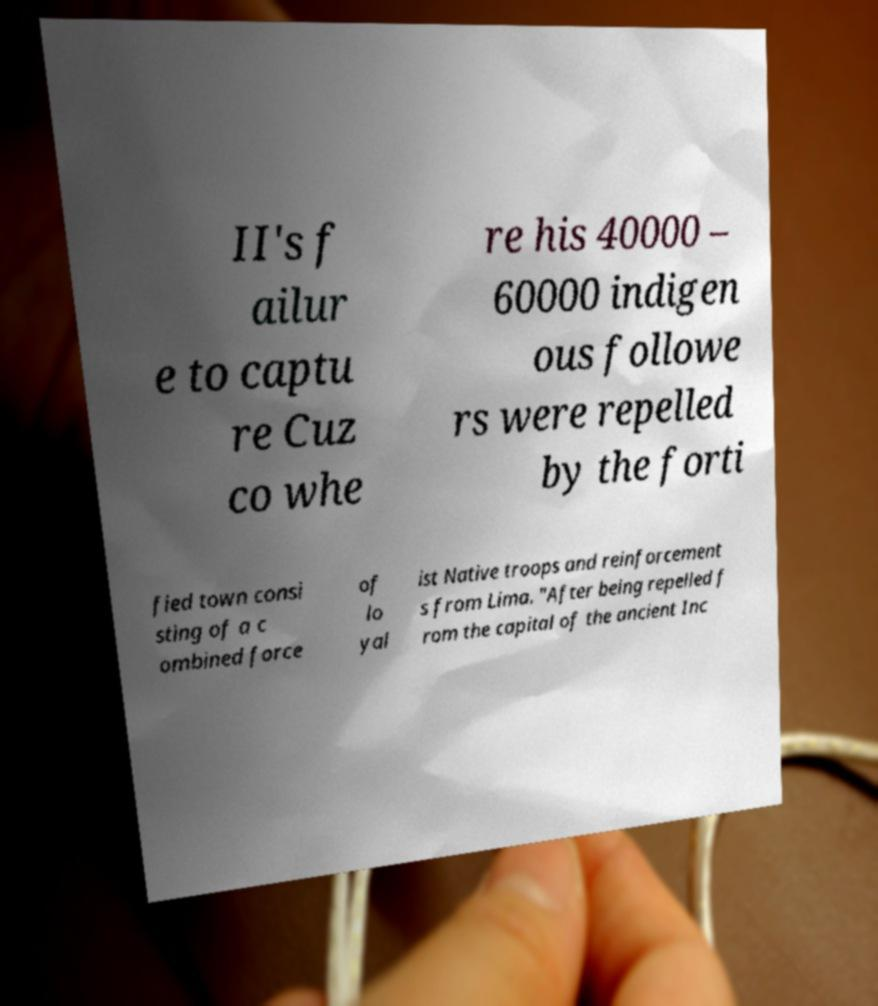For documentation purposes, I need the text within this image transcribed. Could you provide that? II's f ailur e to captu re Cuz co whe re his 40000 – 60000 indigen ous followe rs were repelled by the forti fied town consi sting of a c ombined force of lo yal ist Native troops and reinforcement s from Lima. "After being repelled f rom the capital of the ancient Inc 